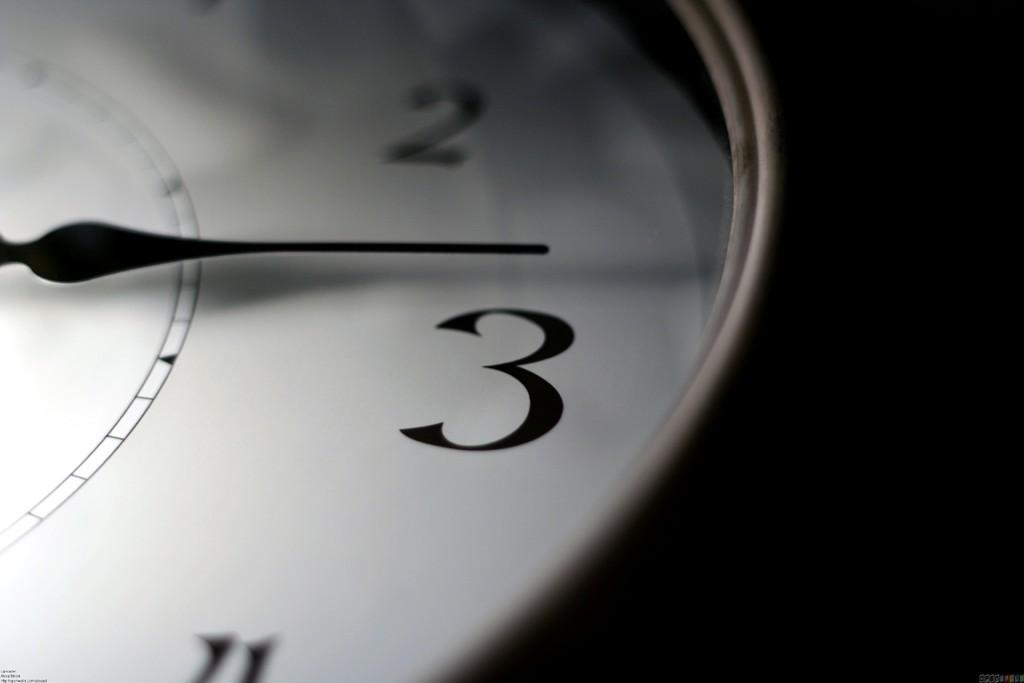What type of object is present on the wall in the image? There is a wall clock in the image. What feature does the wall clock have to indicate time? The wall clock has numbers. How does the wall clock show the current time? The wall clock has a pointer. What type of mitten is being used to start the rifle in the image? There is no mitten or rifle present in the image; it only features a wall clock with numbers and a pointer. 